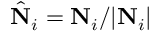<formula> <loc_0><loc_0><loc_500><loc_500>\hat { N } _ { i } = { N } _ { i } / | { N } _ { i } |</formula> 